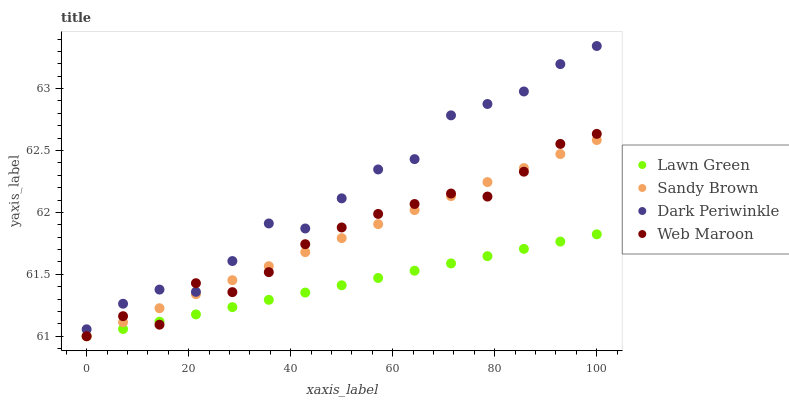Does Lawn Green have the minimum area under the curve?
Answer yes or no. Yes. Does Dark Periwinkle have the maximum area under the curve?
Answer yes or no. Yes. Does Sandy Brown have the minimum area under the curve?
Answer yes or no. No. Does Sandy Brown have the maximum area under the curve?
Answer yes or no. No. Is Lawn Green the smoothest?
Answer yes or no. Yes. Is Dark Periwinkle the roughest?
Answer yes or no. Yes. Is Sandy Brown the smoothest?
Answer yes or no. No. Is Sandy Brown the roughest?
Answer yes or no. No. Does Lawn Green have the lowest value?
Answer yes or no. Yes. Does Dark Periwinkle have the lowest value?
Answer yes or no. No. Does Dark Periwinkle have the highest value?
Answer yes or no. Yes. Does Sandy Brown have the highest value?
Answer yes or no. No. Is Lawn Green less than Dark Periwinkle?
Answer yes or no. Yes. Is Dark Periwinkle greater than Sandy Brown?
Answer yes or no. Yes. Does Dark Periwinkle intersect Web Maroon?
Answer yes or no. Yes. Is Dark Periwinkle less than Web Maroon?
Answer yes or no. No. Is Dark Periwinkle greater than Web Maroon?
Answer yes or no. No. Does Lawn Green intersect Dark Periwinkle?
Answer yes or no. No. 